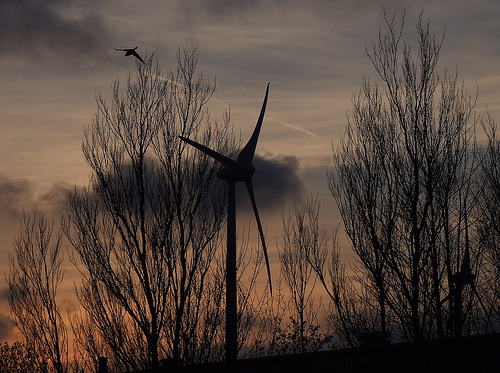<image>
Is the bird above the windmill? Yes. The bird is positioned above the windmill in the vertical space, higher up in the scene. 